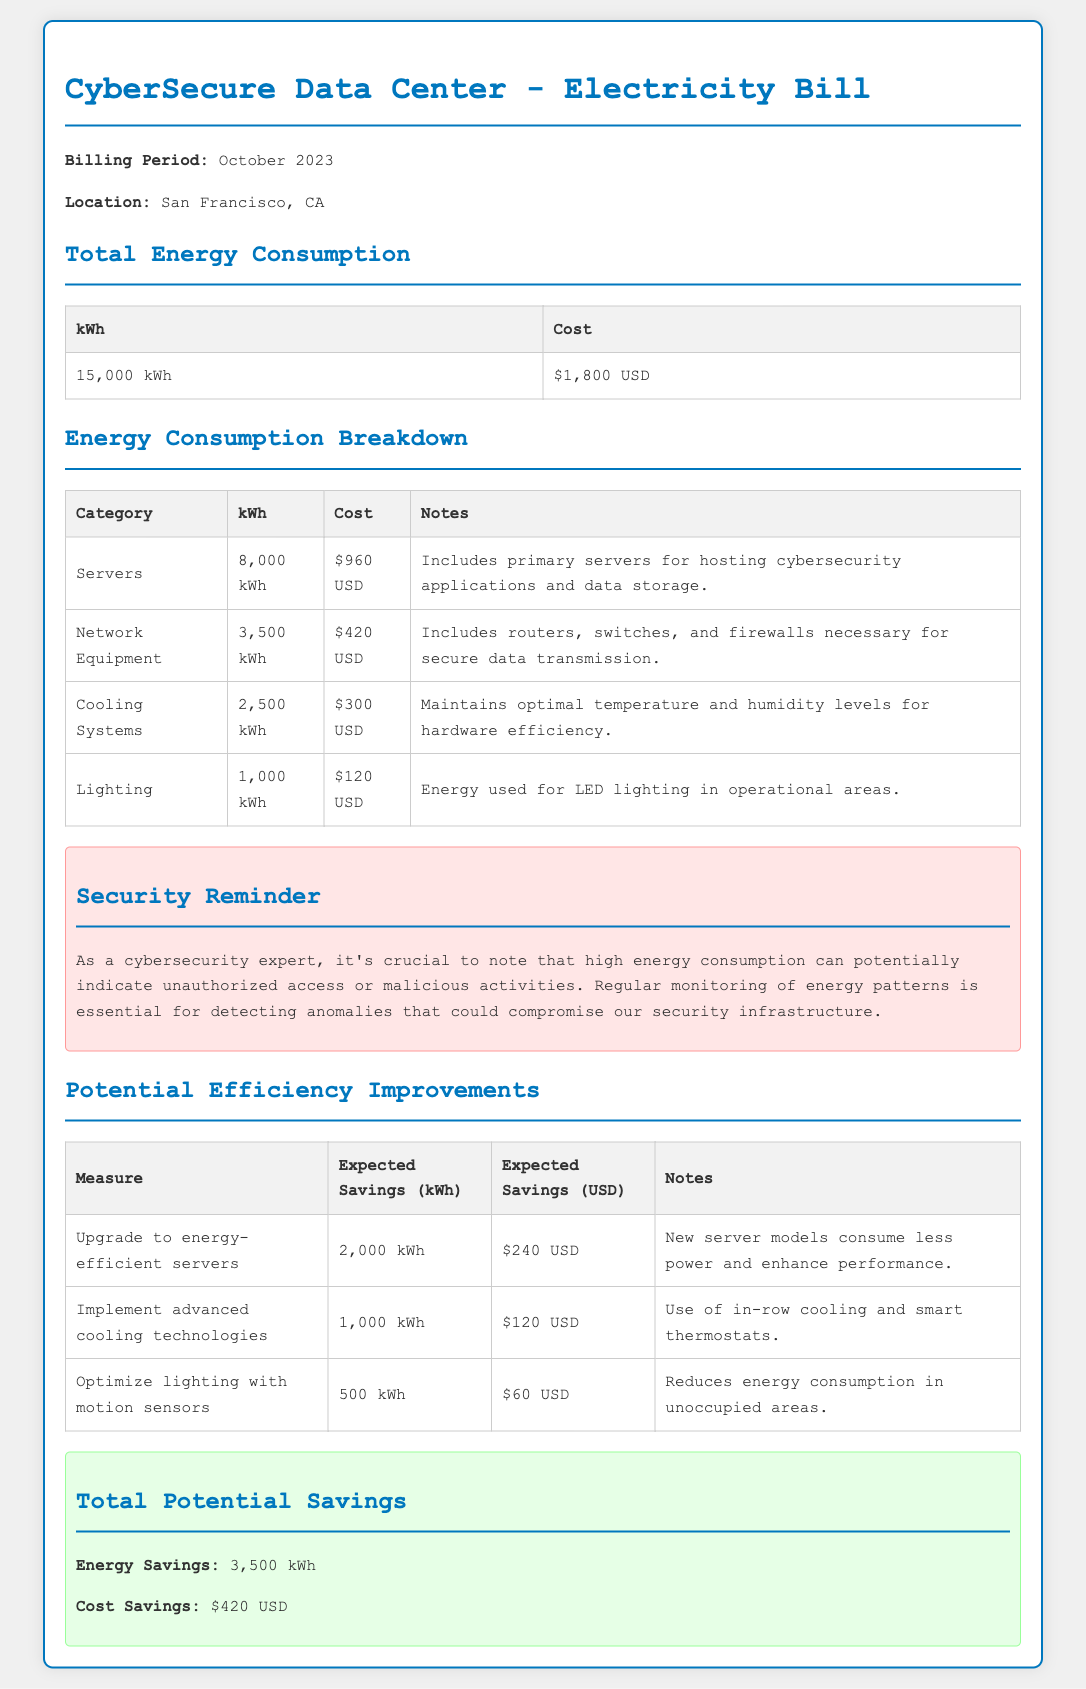What is the total energy consumption? The total energy consumption is the amount of energy used by the data center during the billing period, which is 15,000 kWh.
Answer: 15,000 kWh What is the total cost of the electricity bill? The total cost reflects the amount charged for the total energy consumption of the billing period, which is $1,800 USD.
Answer: $1,800 USD How much energy do the servers consume? The document details the consumption of each category, and servers consume 8,000 kWh.
Answer: 8,000 kWh What is the expected savings from upgrading to energy-efficient servers? The expected savings from this measure is calculated based on reduced energy consumption, which is 2,000 kWh.
Answer: 2,000 kWh Which category has the highest cost? The costs of different categories are listed, and the servers have the highest cost at $960 USD.
Answer: $960 USD What amount is allocated to cooling systems? The cooling systems section provides the allocated cost, which is $300 USD.
Answer: $300 USD What are the total potential cost savings? Total potential cost savings reflect the total expected savings from various efficiency improvements, amounting to $420 USD.
Answer: $420 USD What is the energy savings from optimizing lighting with motion sensors? The energy savings due to this optimization is explicitly mentioned as being 500 kWh.
Answer: 500 kWh What security reminder is highlighted in the document? The document emphasizes the importance of monitoring energy patterns to detect anomalies related to security.
Answer: Monitoring energy patterns 